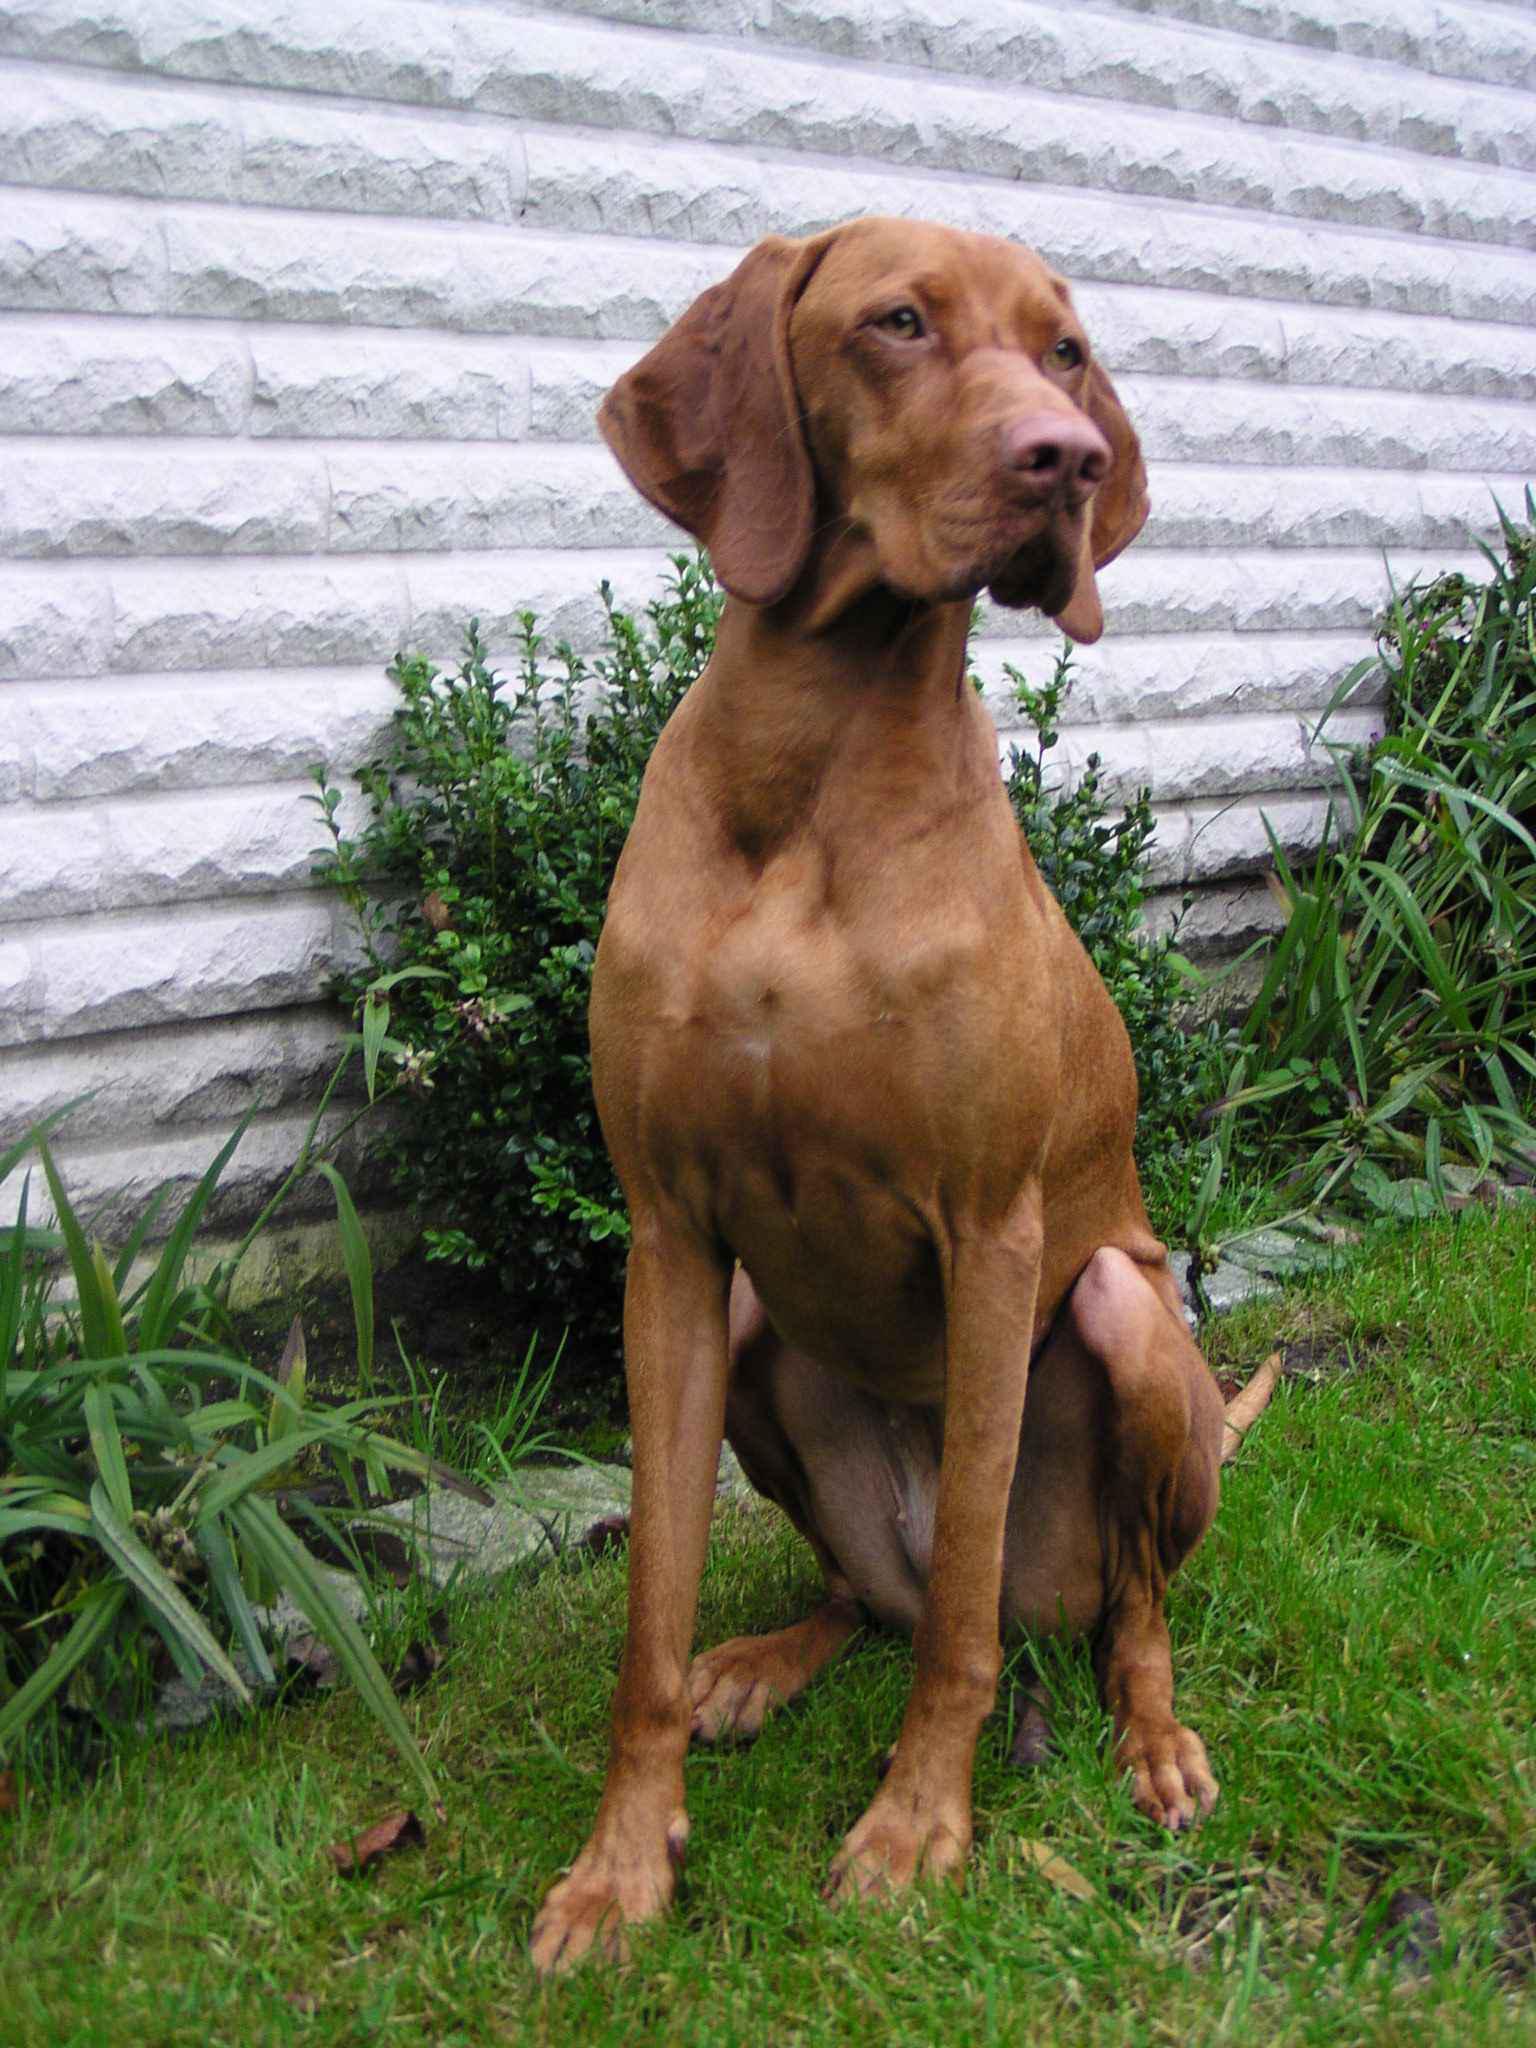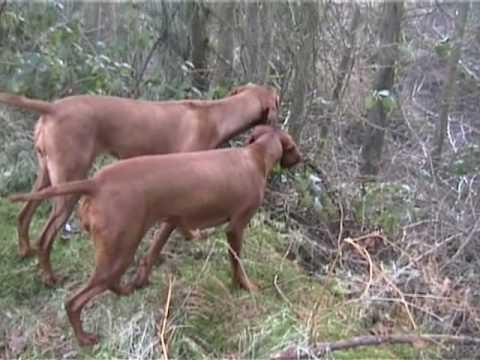The first image is the image on the left, the second image is the image on the right. For the images shown, is this caption "One of the images features a pair of dogs together." true? Answer yes or no. Yes. The first image is the image on the left, the second image is the image on the right. Analyze the images presented: Is the assertion "In one image there is a single dog and in the other image there are 2 dogs." valid? Answer yes or no. Yes. 